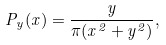<formula> <loc_0><loc_0><loc_500><loc_500>P _ { y } ( x ) = \frac { y } { \pi ( x ^ { 2 } + y ^ { 2 } ) } ,</formula> 